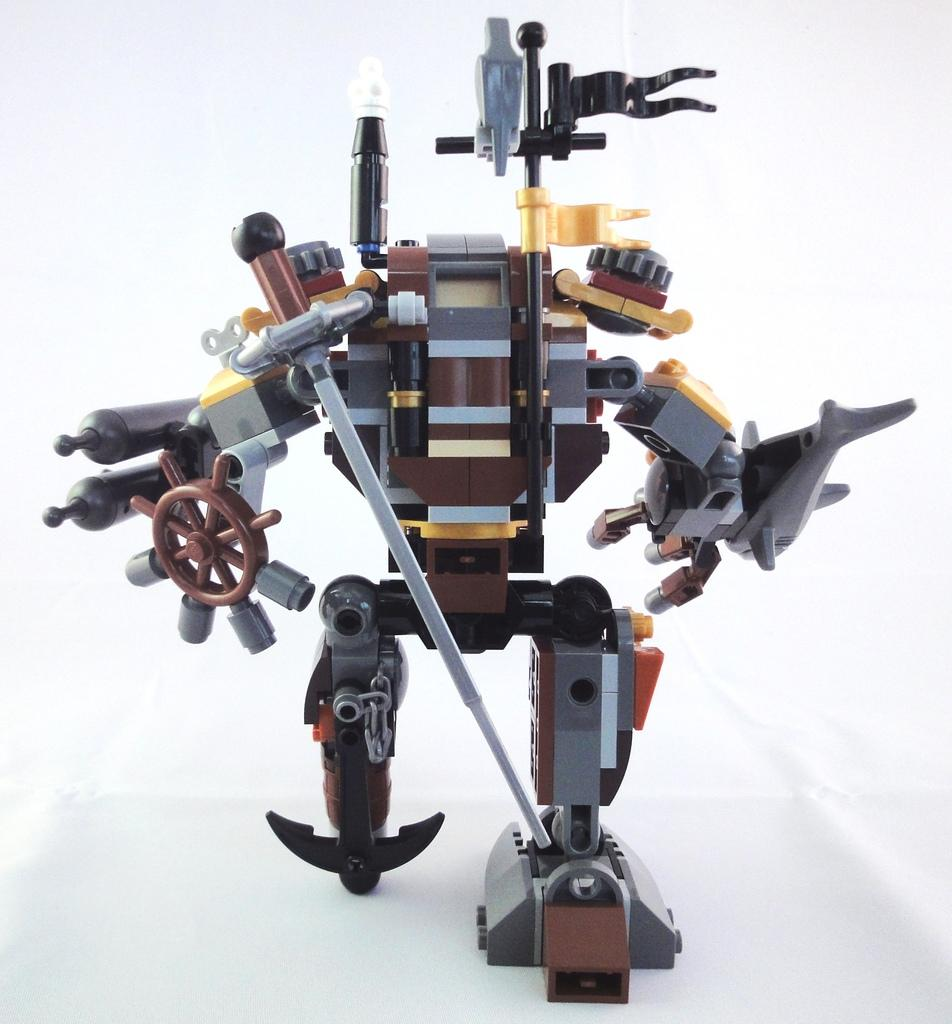What is the main subject of the image? The main subject of the image is a robot. Can you describe the colors of the robot? The robot has brown, black, grey, and yellow colors. What color is the background of the image? The background of the image is white. How many friends does the loaf have in the image? There is no loaf present in the image, and therefore no friends associated with it. 